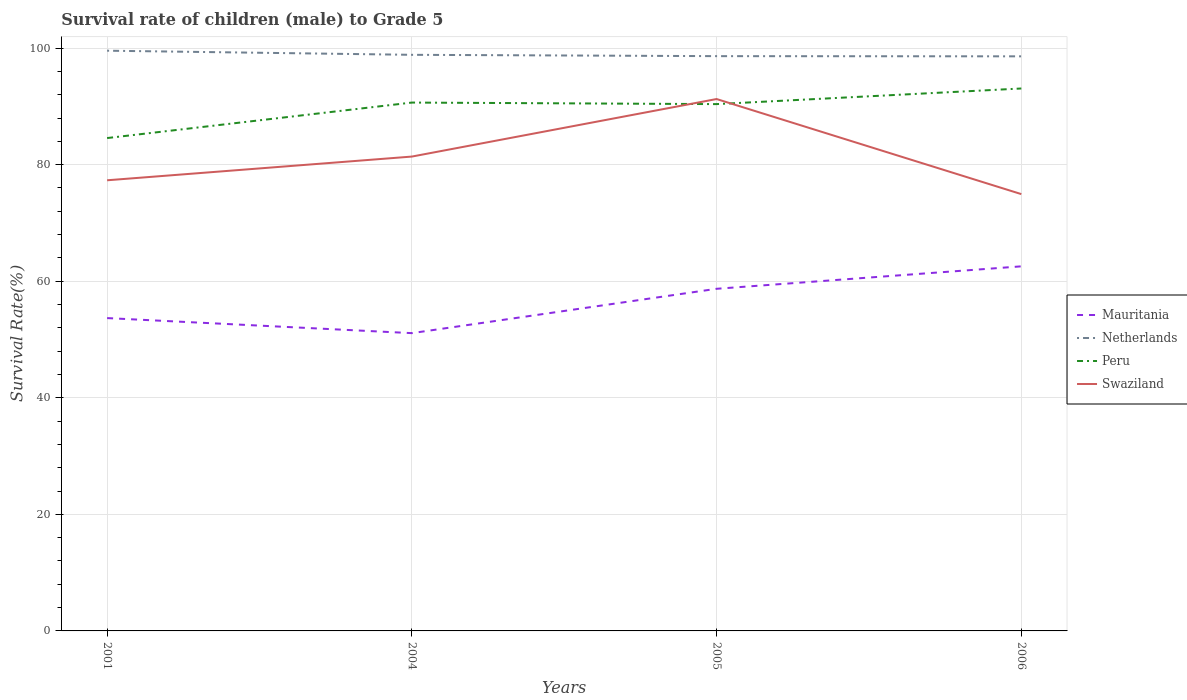How many different coloured lines are there?
Give a very brief answer. 4. Across all years, what is the maximum survival rate of male children to grade 5 in Netherlands?
Offer a very short reply. 98.59. What is the total survival rate of male children to grade 5 in Netherlands in the graph?
Ensure brevity in your answer.  0.26. What is the difference between the highest and the second highest survival rate of male children to grade 5 in Mauritania?
Give a very brief answer. 11.46. Is the survival rate of male children to grade 5 in Swaziland strictly greater than the survival rate of male children to grade 5 in Netherlands over the years?
Provide a short and direct response. Yes. Are the values on the major ticks of Y-axis written in scientific E-notation?
Your response must be concise. No. How many legend labels are there?
Your answer should be compact. 4. How are the legend labels stacked?
Give a very brief answer. Vertical. What is the title of the graph?
Your response must be concise. Survival rate of children (male) to Grade 5. Does "Togo" appear as one of the legend labels in the graph?
Your answer should be very brief. No. What is the label or title of the X-axis?
Your answer should be very brief. Years. What is the label or title of the Y-axis?
Provide a succinct answer. Survival Rate(%). What is the Survival Rate(%) in Mauritania in 2001?
Make the answer very short. 53.68. What is the Survival Rate(%) in Netherlands in 2001?
Give a very brief answer. 99.55. What is the Survival Rate(%) of Peru in 2001?
Offer a terse response. 84.56. What is the Survival Rate(%) of Swaziland in 2001?
Keep it short and to the point. 77.32. What is the Survival Rate(%) in Mauritania in 2004?
Provide a succinct answer. 51.09. What is the Survival Rate(%) in Netherlands in 2004?
Offer a terse response. 98.85. What is the Survival Rate(%) of Peru in 2004?
Provide a succinct answer. 90.65. What is the Survival Rate(%) of Swaziland in 2004?
Give a very brief answer. 81.39. What is the Survival Rate(%) in Mauritania in 2005?
Provide a short and direct response. 58.7. What is the Survival Rate(%) in Netherlands in 2005?
Provide a short and direct response. 98.62. What is the Survival Rate(%) in Peru in 2005?
Provide a short and direct response. 90.39. What is the Survival Rate(%) in Swaziland in 2005?
Your answer should be very brief. 91.26. What is the Survival Rate(%) of Mauritania in 2006?
Ensure brevity in your answer.  62.55. What is the Survival Rate(%) of Netherlands in 2006?
Make the answer very short. 98.59. What is the Survival Rate(%) of Peru in 2006?
Give a very brief answer. 93.07. What is the Survival Rate(%) of Swaziland in 2006?
Ensure brevity in your answer.  74.95. Across all years, what is the maximum Survival Rate(%) in Mauritania?
Your answer should be compact. 62.55. Across all years, what is the maximum Survival Rate(%) of Netherlands?
Offer a very short reply. 99.55. Across all years, what is the maximum Survival Rate(%) of Peru?
Make the answer very short. 93.07. Across all years, what is the maximum Survival Rate(%) of Swaziland?
Ensure brevity in your answer.  91.26. Across all years, what is the minimum Survival Rate(%) in Mauritania?
Provide a succinct answer. 51.09. Across all years, what is the minimum Survival Rate(%) in Netherlands?
Offer a very short reply. 98.59. Across all years, what is the minimum Survival Rate(%) in Peru?
Keep it short and to the point. 84.56. Across all years, what is the minimum Survival Rate(%) in Swaziland?
Make the answer very short. 74.95. What is the total Survival Rate(%) in Mauritania in the graph?
Provide a short and direct response. 226.03. What is the total Survival Rate(%) of Netherlands in the graph?
Give a very brief answer. 395.6. What is the total Survival Rate(%) of Peru in the graph?
Ensure brevity in your answer.  358.67. What is the total Survival Rate(%) in Swaziland in the graph?
Your answer should be compact. 324.92. What is the difference between the Survival Rate(%) in Mauritania in 2001 and that in 2004?
Provide a succinct answer. 2.58. What is the difference between the Survival Rate(%) of Netherlands in 2001 and that in 2004?
Your answer should be very brief. 0.71. What is the difference between the Survival Rate(%) in Peru in 2001 and that in 2004?
Offer a very short reply. -6.09. What is the difference between the Survival Rate(%) in Swaziland in 2001 and that in 2004?
Your answer should be very brief. -4.07. What is the difference between the Survival Rate(%) in Mauritania in 2001 and that in 2005?
Make the answer very short. -5.03. What is the difference between the Survival Rate(%) in Netherlands in 2001 and that in 2005?
Your answer should be very brief. 0.93. What is the difference between the Survival Rate(%) in Peru in 2001 and that in 2005?
Make the answer very short. -5.83. What is the difference between the Survival Rate(%) in Swaziland in 2001 and that in 2005?
Offer a very short reply. -13.94. What is the difference between the Survival Rate(%) in Mauritania in 2001 and that in 2006?
Ensure brevity in your answer.  -8.88. What is the difference between the Survival Rate(%) in Netherlands in 2001 and that in 2006?
Offer a terse response. 0.97. What is the difference between the Survival Rate(%) in Peru in 2001 and that in 2006?
Your answer should be compact. -8.51. What is the difference between the Survival Rate(%) in Swaziland in 2001 and that in 2006?
Ensure brevity in your answer.  2.37. What is the difference between the Survival Rate(%) in Mauritania in 2004 and that in 2005?
Provide a succinct answer. -7.61. What is the difference between the Survival Rate(%) of Netherlands in 2004 and that in 2005?
Your answer should be very brief. 0.23. What is the difference between the Survival Rate(%) in Peru in 2004 and that in 2005?
Provide a succinct answer. 0.26. What is the difference between the Survival Rate(%) of Swaziland in 2004 and that in 2005?
Give a very brief answer. -9.87. What is the difference between the Survival Rate(%) of Mauritania in 2004 and that in 2006?
Your response must be concise. -11.46. What is the difference between the Survival Rate(%) in Netherlands in 2004 and that in 2006?
Provide a succinct answer. 0.26. What is the difference between the Survival Rate(%) in Peru in 2004 and that in 2006?
Give a very brief answer. -2.42. What is the difference between the Survival Rate(%) of Swaziland in 2004 and that in 2006?
Your answer should be compact. 6.44. What is the difference between the Survival Rate(%) in Mauritania in 2005 and that in 2006?
Your answer should be very brief. -3.85. What is the difference between the Survival Rate(%) in Netherlands in 2005 and that in 2006?
Provide a succinct answer. 0.03. What is the difference between the Survival Rate(%) in Peru in 2005 and that in 2006?
Give a very brief answer. -2.68. What is the difference between the Survival Rate(%) of Swaziland in 2005 and that in 2006?
Offer a terse response. 16.31. What is the difference between the Survival Rate(%) of Mauritania in 2001 and the Survival Rate(%) of Netherlands in 2004?
Your answer should be compact. -45.17. What is the difference between the Survival Rate(%) of Mauritania in 2001 and the Survival Rate(%) of Peru in 2004?
Offer a very short reply. -36.98. What is the difference between the Survival Rate(%) of Mauritania in 2001 and the Survival Rate(%) of Swaziland in 2004?
Make the answer very short. -27.71. What is the difference between the Survival Rate(%) of Netherlands in 2001 and the Survival Rate(%) of Peru in 2004?
Provide a short and direct response. 8.9. What is the difference between the Survival Rate(%) in Netherlands in 2001 and the Survival Rate(%) in Swaziland in 2004?
Ensure brevity in your answer.  18.17. What is the difference between the Survival Rate(%) of Peru in 2001 and the Survival Rate(%) of Swaziland in 2004?
Offer a terse response. 3.18. What is the difference between the Survival Rate(%) in Mauritania in 2001 and the Survival Rate(%) in Netherlands in 2005?
Provide a short and direct response. -44.94. What is the difference between the Survival Rate(%) of Mauritania in 2001 and the Survival Rate(%) of Peru in 2005?
Offer a very short reply. -36.71. What is the difference between the Survival Rate(%) in Mauritania in 2001 and the Survival Rate(%) in Swaziland in 2005?
Make the answer very short. -37.58. What is the difference between the Survival Rate(%) in Netherlands in 2001 and the Survival Rate(%) in Peru in 2005?
Keep it short and to the point. 9.16. What is the difference between the Survival Rate(%) in Netherlands in 2001 and the Survival Rate(%) in Swaziland in 2005?
Your response must be concise. 8.29. What is the difference between the Survival Rate(%) of Peru in 2001 and the Survival Rate(%) of Swaziland in 2005?
Ensure brevity in your answer.  -6.7. What is the difference between the Survival Rate(%) of Mauritania in 2001 and the Survival Rate(%) of Netherlands in 2006?
Make the answer very short. -44.91. What is the difference between the Survival Rate(%) of Mauritania in 2001 and the Survival Rate(%) of Peru in 2006?
Your answer should be very brief. -39.39. What is the difference between the Survival Rate(%) of Mauritania in 2001 and the Survival Rate(%) of Swaziland in 2006?
Your response must be concise. -21.27. What is the difference between the Survival Rate(%) in Netherlands in 2001 and the Survival Rate(%) in Peru in 2006?
Keep it short and to the point. 6.48. What is the difference between the Survival Rate(%) of Netherlands in 2001 and the Survival Rate(%) of Swaziland in 2006?
Provide a succinct answer. 24.61. What is the difference between the Survival Rate(%) of Peru in 2001 and the Survival Rate(%) of Swaziland in 2006?
Provide a succinct answer. 9.62. What is the difference between the Survival Rate(%) in Mauritania in 2004 and the Survival Rate(%) in Netherlands in 2005?
Your answer should be compact. -47.53. What is the difference between the Survival Rate(%) in Mauritania in 2004 and the Survival Rate(%) in Peru in 2005?
Offer a very short reply. -39.3. What is the difference between the Survival Rate(%) of Mauritania in 2004 and the Survival Rate(%) of Swaziland in 2005?
Offer a terse response. -40.17. What is the difference between the Survival Rate(%) of Netherlands in 2004 and the Survival Rate(%) of Peru in 2005?
Ensure brevity in your answer.  8.46. What is the difference between the Survival Rate(%) of Netherlands in 2004 and the Survival Rate(%) of Swaziland in 2005?
Keep it short and to the point. 7.59. What is the difference between the Survival Rate(%) in Peru in 2004 and the Survival Rate(%) in Swaziland in 2005?
Your answer should be very brief. -0.61. What is the difference between the Survival Rate(%) of Mauritania in 2004 and the Survival Rate(%) of Netherlands in 2006?
Your answer should be compact. -47.49. What is the difference between the Survival Rate(%) in Mauritania in 2004 and the Survival Rate(%) in Peru in 2006?
Ensure brevity in your answer.  -41.98. What is the difference between the Survival Rate(%) in Mauritania in 2004 and the Survival Rate(%) in Swaziland in 2006?
Offer a terse response. -23.85. What is the difference between the Survival Rate(%) of Netherlands in 2004 and the Survival Rate(%) of Peru in 2006?
Provide a succinct answer. 5.78. What is the difference between the Survival Rate(%) of Netherlands in 2004 and the Survival Rate(%) of Swaziland in 2006?
Make the answer very short. 23.9. What is the difference between the Survival Rate(%) of Peru in 2004 and the Survival Rate(%) of Swaziland in 2006?
Your answer should be compact. 15.71. What is the difference between the Survival Rate(%) of Mauritania in 2005 and the Survival Rate(%) of Netherlands in 2006?
Keep it short and to the point. -39.88. What is the difference between the Survival Rate(%) of Mauritania in 2005 and the Survival Rate(%) of Peru in 2006?
Offer a terse response. -34.37. What is the difference between the Survival Rate(%) of Mauritania in 2005 and the Survival Rate(%) of Swaziland in 2006?
Your answer should be compact. -16.25. What is the difference between the Survival Rate(%) of Netherlands in 2005 and the Survival Rate(%) of Peru in 2006?
Your answer should be very brief. 5.55. What is the difference between the Survival Rate(%) in Netherlands in 2005 and the Survival Rate(%) in Swaziland in 2006?
Your response must be concise. 23.67. What is the difference between the Survival Rate(%) in Peru in 2005 and the Survival Rate(%) in Swaziland in 2006?
Your answer should be compact. 15.44. What is the average Survival Rate(%) of Mauritania per year?
Offer a very short reply. 56.51. What is the average Survival Rate(%) of Netherlands per year?
Offer a terse response. 98.9. What is the average Survival Rate(%) in Peru per year?
Your answer should be compact. 89.67. What is the average Survival Rate(%) of Swaziland per year?
Provide a short and direct response. 81.23. In the year 2001, what is the difference between the Survival Rate(%) in Mauritania and Survival Rate(%) in Netherlands?
Give a very brief answer. -45.88. In the year 2001, what is the difference between the Survival Rate(%) of Mauritania and Survival Rate(%) of Peru?
Keep it short and to the point. -30.89. In the year 2001, what is the difference between the Survival Rate(%) in Mauritania and Survival Rate(%) in Swaziland?
Offer a terse response. -23.64. In the year 2001, what is the difference between the Survival Rate(%) of Netherlands and Survival Rate(%) of Peru?
Your answer should be compact. 14.99. In the year 2001, what is the difference between the Survival Rate(%) of Netherlands and Survival Rate(%) of Swaziland?
Keep it short and to the point. 22.23. In the year 2001, what is the difference between the Survival Rate(%) of Peru and Survival Rate(%) of Swaziland?
Your answer should be compact. 7.24. In the year 2004, what is the difference between the Survival Rate(%) in Mauritania and Survival Rate(%) in Netherlands?
Keep it short and to the point. -47.75. In the year 2004, what is the difference between the Survival Rate(%) in Mauritania and Survival Rate(%) in Peru?
Offer a very short reply. -39.56. In the year 2004, what is the difference between the Survival Rate(%) of Mauritania and Survival Rate(%) of Swaziland?
Keep it short and to the point. -30.29. In the year 2004, what is the difference between the Survival Rate(%) of Netherlands and Survival Rate(%) of Peru?
Provide a succinct answer. 8.19. In the year 2004, what is the difference between the Survival Rate(%) in Netherlands and Survival Rate(%) in Swaziland?
Keep it short and to the point. 17.46. In the year 2004, what is the difference between the Survival Rate(%) of Peru and Survival Rate(%) of Swaziland?
Offer a very short reply. 9.27. In the year 2005, what is the difference between the Survival Rate(%) in Mauritania and Survival Rate(%) in Netherlands?
Ensure brevity in your answer.  -39.92. In the year 2005, what is the difference between the Survival Rate(%) in Mauritania and Survival Rate(%) in Peru?
Offer a very short reply. -31.69. In the year 2005, what is the difference between the Survival Rate(%) of Mauritania and Survival Rate(%) of Swaziland?
Make the answer very short. -32.56. In the year 2005, what is the difference between the Survival Rate(%) in Netherlands and Survival Rate(%) in Peru?
Provide a succinct answer. 8.23. In the year 2005, what is the difference between the Survival Rate(%) in Netherlands and Survival Rate(%) in Swaziland?
Give a very brief answer. 7.36. In the year 2005, what is the difference between the Survival Rate(%) of Peru and Survival Rate(%) of Swaziland?
Offer a very short reply. -0.87. In the year 2006, what is the difference between the Survival Rate(%) in Mauritania and Survival Rate(%) in Netherlands?
Give a very brief answer. -36.03. In the year 2006, what is the difference between the Survival Rate(%) in Mauritania and Survival Rate(%) in Peru?
Provide a short and direct response. -30.52. In the year 2006, what is the difference between the Survival Rate(%) in Mauritania and Survival Rate(%) in Swaziland?
Your answer should be compact. -12.39. In the year 2006, what is the difference between the Survival Rate(%) of Netherlands and Survival Rate(%) of Peru?
Provide a succinct answer. 5.52. In the year 2006, what is the difference between the Survival Rate(%) in Netherlands and Survival Rate(%) in Swaziland?
Ensure brevity in your answer.  23.64. In the year 2006, what is the difference between the Survival Rate(%) in Peru and Survival Rate(%) in Swaziland?
Ensure brevity in your answer.  18.12. What is the ratio of the Survival Rate(%) of Mauritania in 2001 to that in 2004?
Your answer should be compact. 1.05. What is the ratio of the Survival Rate(%) of Netherlands in 2001 to that in 2004?
Make the answer very short. 1.01. What is the ratio of the Survival Rate(%) in Peru in 2001 to that in 2004?
Give a very brief answer. 0.93. What is the ratio of the Survival Rate(%) in Mauritania in 2001 to that in 2005?
Make the answer very short. 0.91. What is the ratio of the Survival Rate(%) in Netherlands in 2001 to that in 2005?
Keep it short and to the point. 1.01. What is the ratio of the Survival Rate(%) in Peru in 2001 to that in 2005?
Your answer should be very brief. 0.94. What is the ratio of the Survival Rate(%) in Swaziland in 2001 to that in 2005?
Your answer should be very brief. 0.85. What is the ratio of the Survival Rate(%) in Mauritania in 2001 to that in 2006?
Your answer should be very brief. 0.86. What is the ratio of the Survival Rate(%) in Netherlands in 2001 to that in 2006?
Make the answer very short. 1.01. What is the ratio of the Survival Rate(%) of Peru in 2001 to that in 2006?
Provide a succinct answer. 0.91. What is the ratio of the Survival Rate(%) in Swaziland in 2001 to that in 2006?
Offer a terse response. 1.03. What is the ratio of the Survival Rate(%) of Mauritania in 2004 to that in 2005?
Your answer should be compact. 0.87. What is the ratio of the Survival Rate(%) of Netherlands in 2004 to that in 2005?
Offer a very short reply. 1. What is the ratio of the Survival Rate(%) in Swaziland in 2004 to that in 2005?
Ensure brevity in your answer.  0.89. What is the ratio of the Survival Rate(%) in Mauritania in 2004 to that in 2006?
Provide a succinct answer. 0.82. What is the ratio of the Survival Rate(%) of Netherlands in 2004 to that in 2006?
Your answer should be very brief. 1. What is the ratio of the Survival Rate(%) in Peru in 2004 to that in 2006?
Provide a succinct answer. 0.97. What is the ratio of the Survival Rate(%) of Swaziland in 2004 to that in 2006?
Your response must be concise. 1.09. What is the ratio of the Survival Rate(%) of Mauritania in 2005 to that in 2006?
Give a very brief answer. 0.94. What is the ratio of the Survival Rate(%) of Peru in 2005 to that in 2006?
Give a very brief answer. 0.97. What is the ratio of the Survival Rate(%) in Swaziland in 2005 to that in 2006?
Keep it short and to the point. 1.22. What is the difference between the highest and the second highest Survival Rate(%) of Mauritania?
Your answer should be very brief. 3.85. What is the difference between the highest and the second highest Survival Rate(%) of Netherlands?
Offer a very short reply. 0.71. What is the difference between the highest and the second highest Survival Rate(%) in Peru?
Provide a succinct answer. 2.42. What is the difference between the highest and the second highest Survival Rate(%) of Swaziland?
Make the answer very short. 9.87. What is the difference between the highest and the lowest Survival Rate(%) in Mauritania?
Provide a succinct answer. 11.46. What is the difference between the highest and the lowest Survival Rate(%) of Netherlands?
Your answer should be very brief. 0.97. What is the difference between the highest and the lowest Survival Rate(%) of Peru?
Offer a terse response. 8.51. What is the difference between the highest and the lowest Survival Rate(%) of Swaziland?
Ensure brevity in your answer.  16.31. 